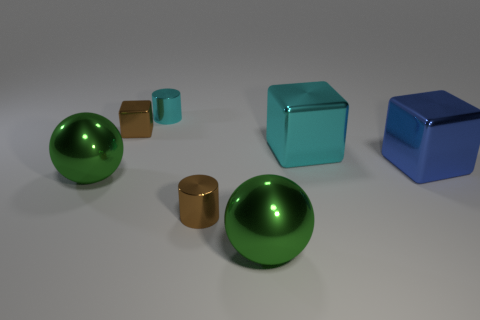Add 1 tiny metallic cylinders. How many objects exist? 8 Subtract all large blocks. How many blocks are left? 1 Subtract all cylinders. How many objects are left? 5 Add 2 blue shiny objects. How many blue shiny objects exist? 3 Subtract 1 green balls. How many objects are left? 6 Subtract all red matte cubes. Subtract all large green spheres. How many objects are left? 5 Add 2 brown metal cylinders. How many brown metal cylinders are left? 3 